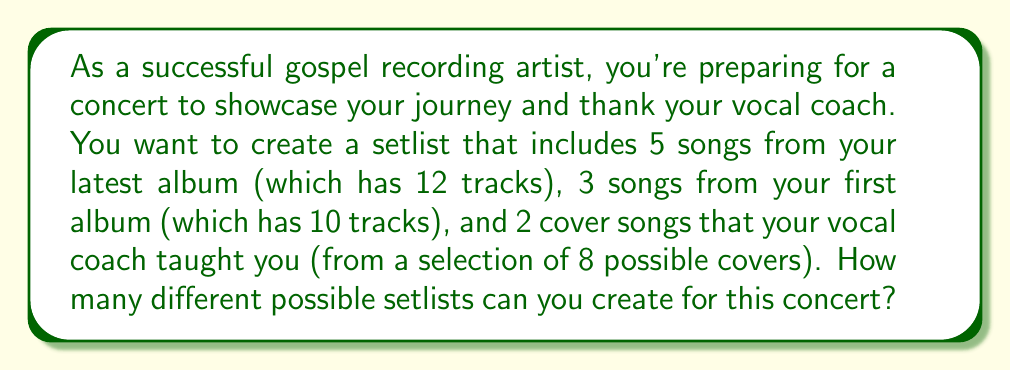Show me your answer to this math problem. To solve this problem, we'll use the multiplication principle of counting. We'll break it down into three parts:

1. Choosing 5 songs from the latest album:
   We need to select 5 songs out of 12. This is a combination problem.
   $$\binom{12}{5} = \frac{12!}{5!(12-5)!} = \frac{12!}{5!7!} = 792$$

2. Choosing 3 songs from the first album:
   We need to select 3 songs out of 10. Again, this is a combination.
   $$\binom{10}{3} = \frac{10!}{3!(10-3)!} = \frac{10!}{3!7!} = 120$$

3. Choosing 2 cover songs:
   We need to select 2 songs out of 8. Another combination.
   $$\binom{8}{2} = \frac{8!}{2!(8-2)!} = \frac{8!}{2!6!} = 28$$

Now, for each possible selection from the latest album, we can have any selection from the first album, and for each of those combinations, we can have any selection of cover songs.

Therefore, we multiply these numbers together:

$$792 \times 120 \times 28 = 2,654,208$$

This gives us the total number of possible setlists.
Answer: 2,654,208 possible setlists 